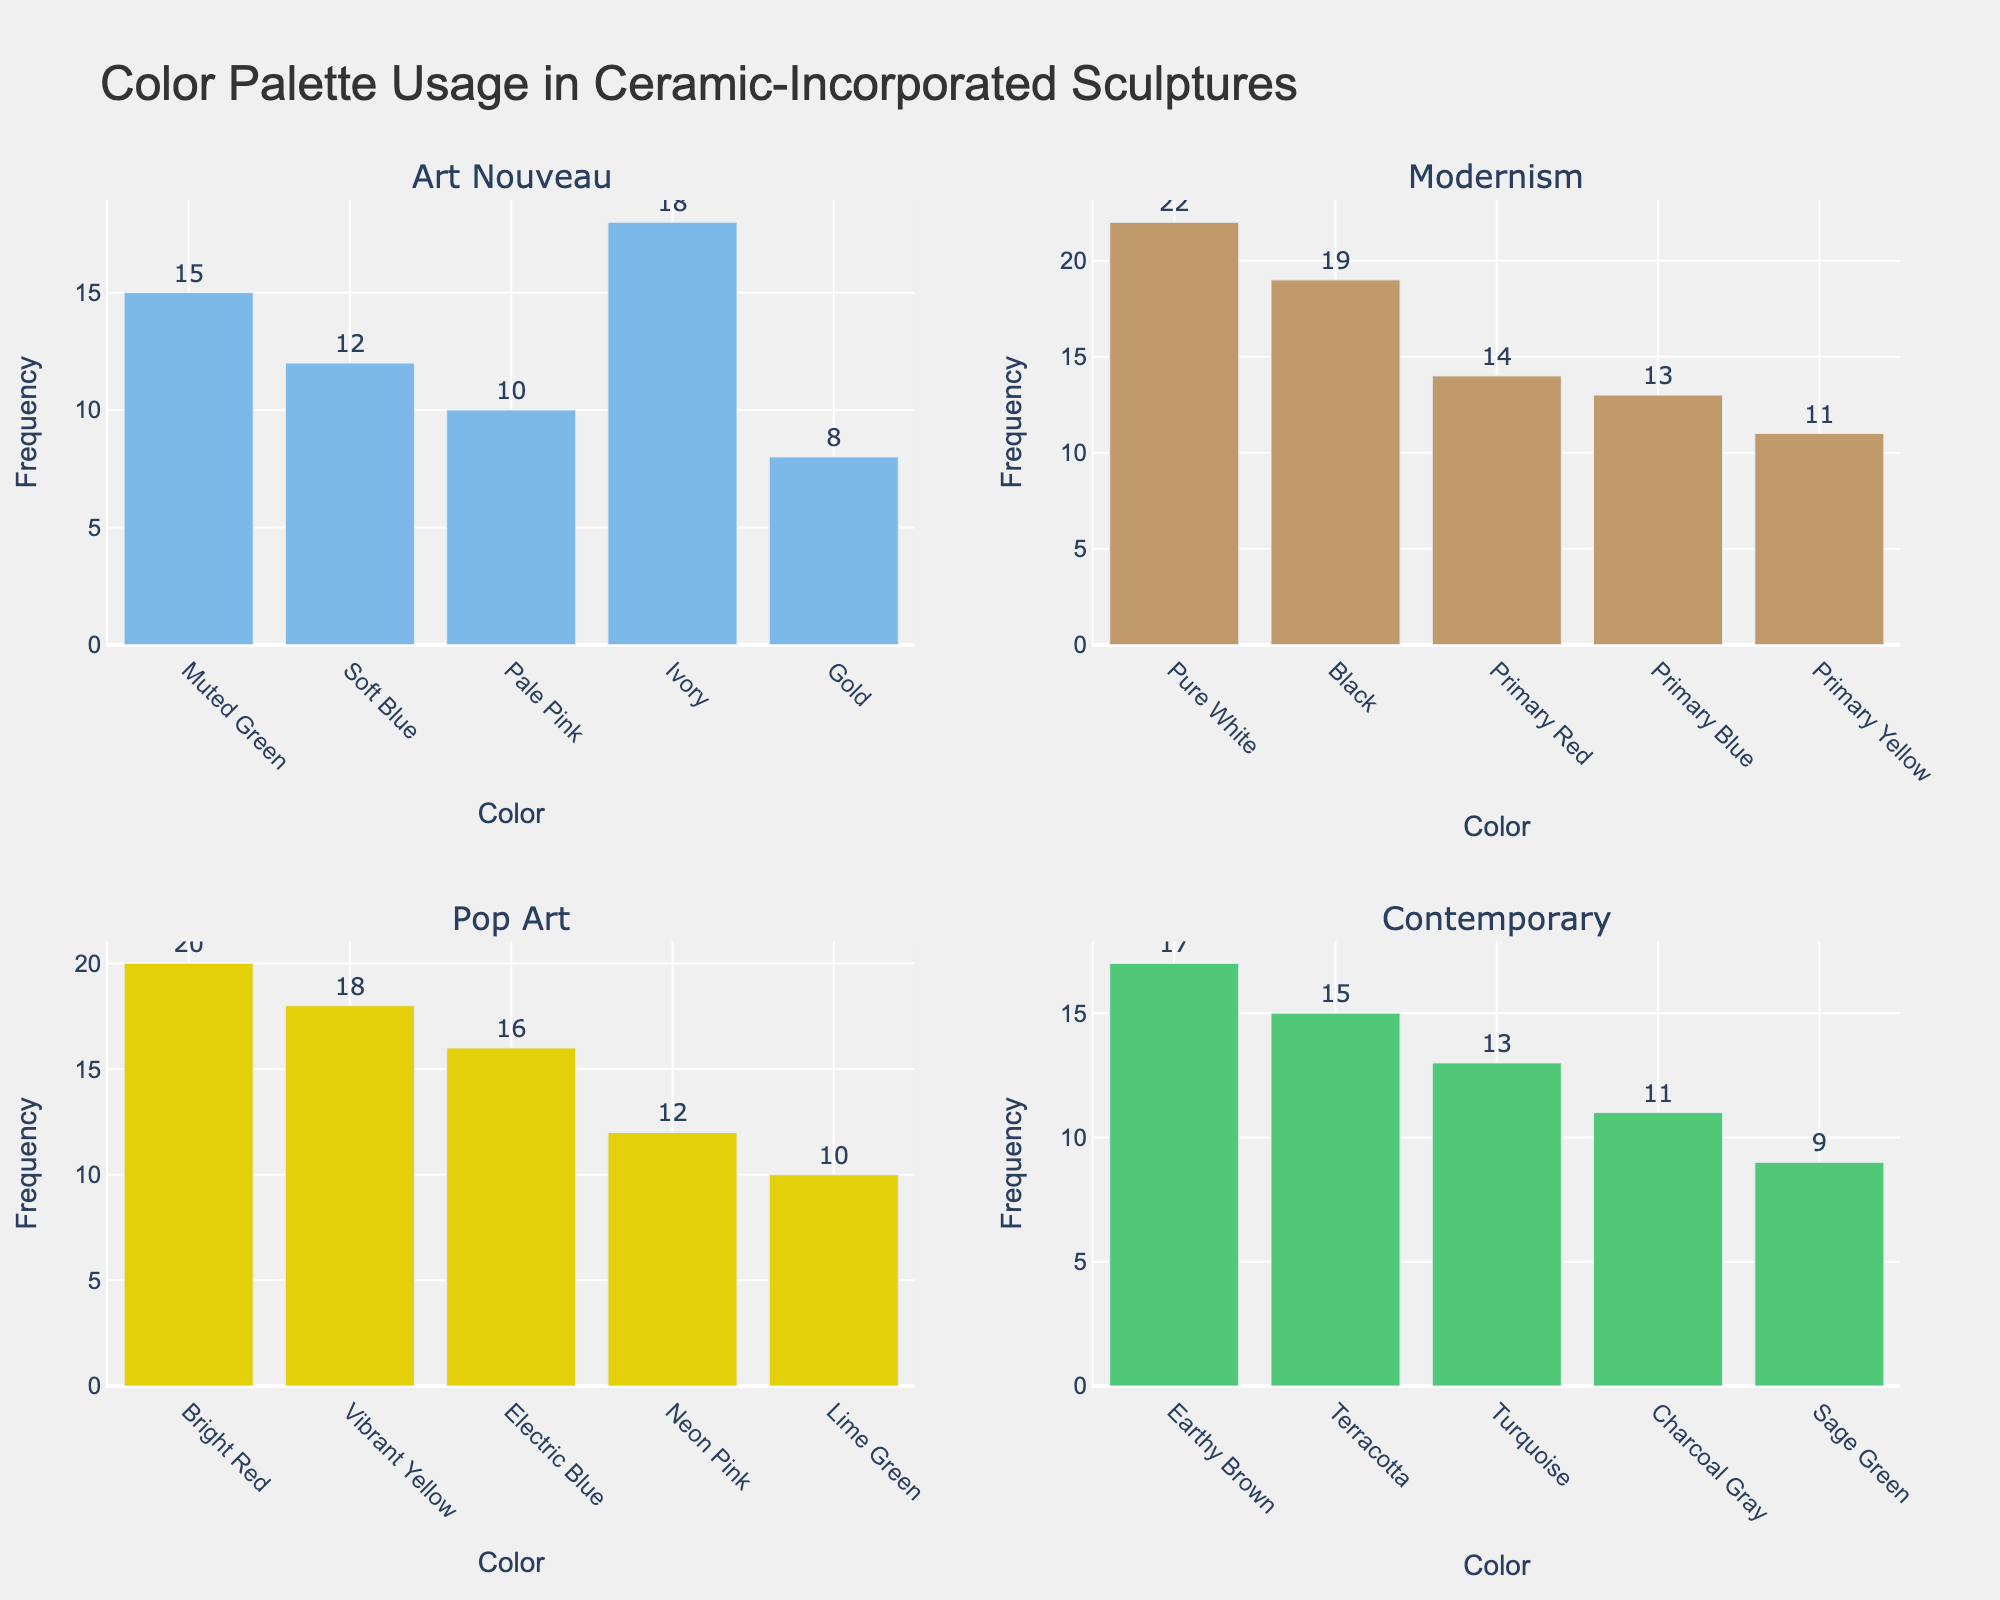What is the title of the figure? The title of the figure is prominently displayed at the top of the image. It summarizes the content being visualized.
Answer: Color Palette Usage in Ceramic-Incorporated Sculptures Which art movement uses the color 'Bright Red' the most? To find this, look for the 'Bright Red' bar in the subplot descriptors and check its corresponding height.
Answer: Pop Art How many colors are displayed for the Contemporary art movement? Count the different bars in the subplot for Contemporary art movement.
Answer: 5 Which art movement prefers using shades of blue the most? Compare the heights of bars representing blue shades ('Soft Blue', 'Primary Blue', 'Electric Blue', 'Turquoise') across all subplots. The movement with the highest total frequency of these bars uses blue the most.
Answer: Pop Art Which color appears the least in Modernism? Identify the shortest bar within the Modernism subplot.
Answer: Primary Yellow What is the most commonly used color in Art Nouveau? Find the tallest bar in the Art Nouveau subplot.
Answer: Ivory Among all art movements, which has the highest frequency for a single color? Compare the tallest bar across all subplots.
Answer: Modernism with Pure White What is the combined frequency of 'Primary Red' and 'Primary Blue' in Modernism? Sum the heights of the bars for 'Primary Red' and 'Primary Blue' within the Modernism subplot.
Answer: 27 Does any art movement use the same number of colors? Observe if any movements have exactly five color bars.
Answer: Yes, Pop Art and Contemporary What is the average frequency of colors in the Art Nouveau movement? Sum the frequencies of all colors in Art Nouveau and divide by the total number of colors in this subplot. So, (15 + 12 + 10 + 18 + 8) / 5 = 63 / 5 = 12.6
Answer: 12.6 